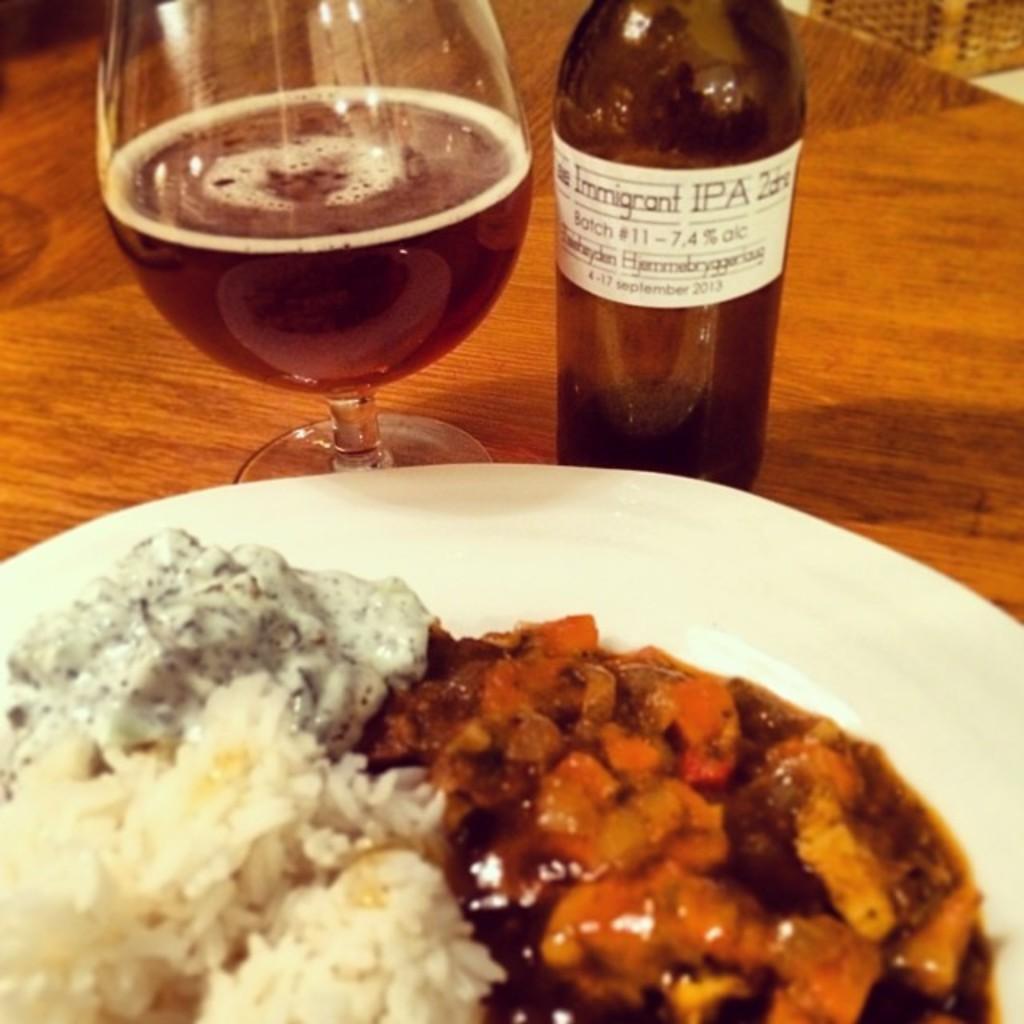How would you summarize this image in a sentence or two? In the middle of the image there is a table on the table there is a plate and food and there is a bottle and there is a glass. 